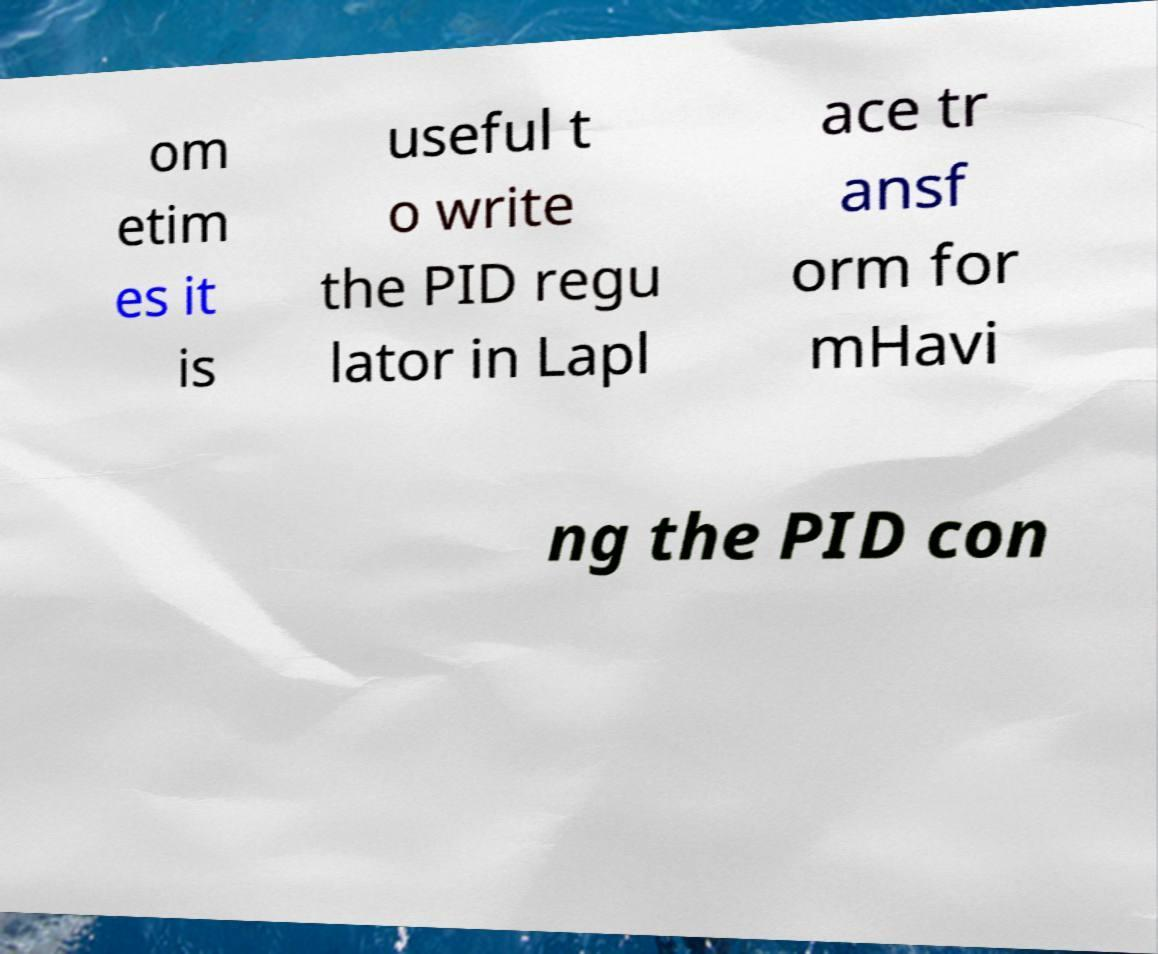I need the written content from this picture converted into text. Can you do that? om etim es it is useful t o write the PID regu lator in Lapl ace tr ansf orm for mHavi ng the PID con 